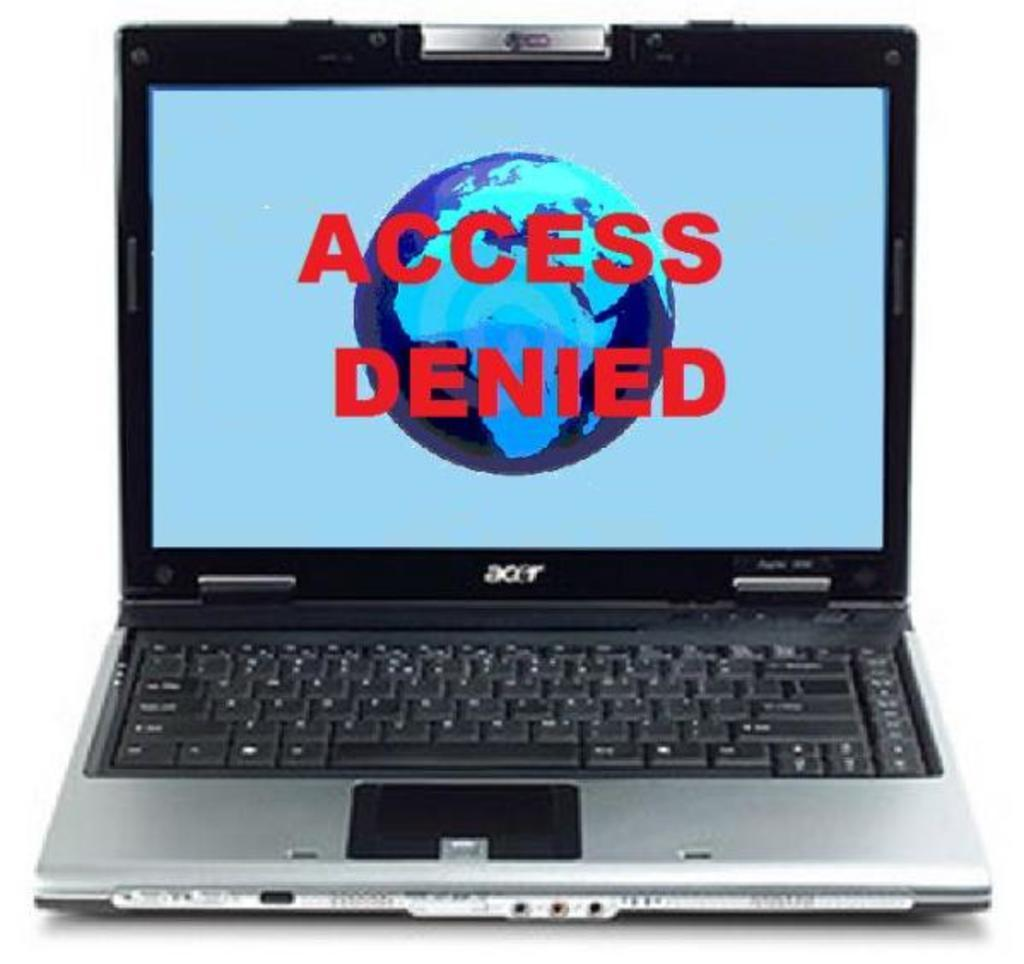<image>
Create a compact narrative representing the image presented. an open acer laptop with a picture of the earth and access denied written in red 